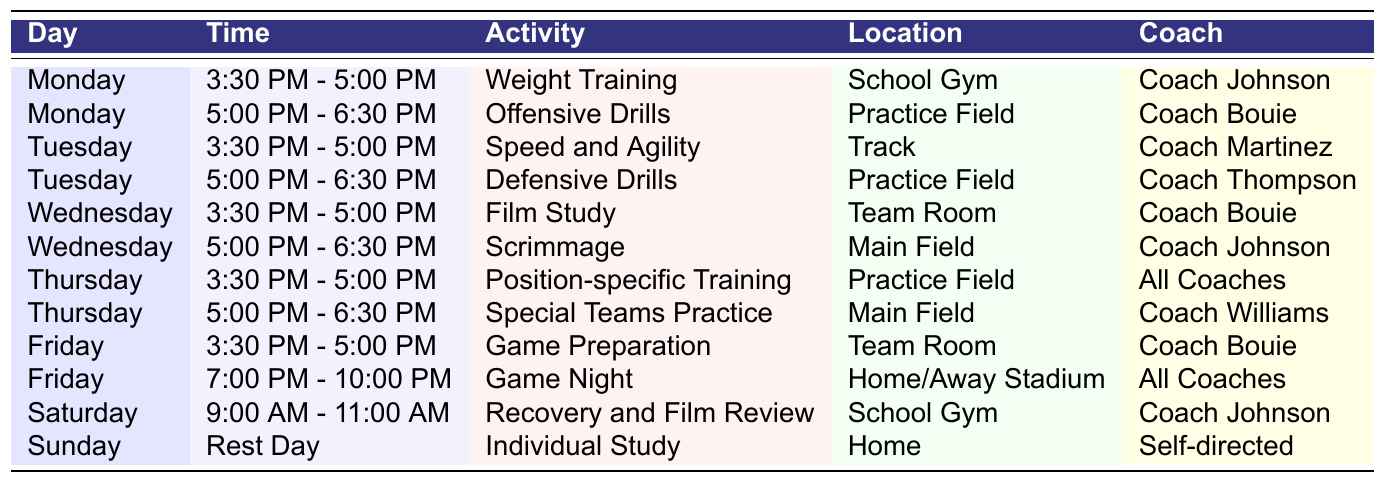What activities take place on Wednesday? The table lists the activities scheduled for Wednesday, which are Film Study from 3:30 PM - 5:00 PM in the Team Room with Coach Bouie, and Scrimmage from 5:00 PM - 6:30 PM on the Main Field with Coach Johnson.
Answer: Film Study and Scrimmage Which coach is responsible for the Defensive Drills? According to the table, the activity for Defensive Drills is scheduled on Tuesday from 5:00 PM - 6:30 PM in the Practice Field, and it is led by Coach Thompson.
Answer: Coach Thompson How many different activities occur on Thursday? The table specifies that two activities are scheduled on Thursday: Position-specific Training from 3:30 PM - 5:00 PM, and Special Teams Practice from 5:00 PM - 6:30 PM. Therefore, there are 2 activities on that day.
Answer: 2 What is the time slot for Game Night? The entry for Game Night indicates that it occurs on Friday from 7:00 PM - 10:00 PM at Home/Away Stadium, as reflected in the table.
Answer: 7:00 PM - 10:00 PM Is there any activity on Sunday? The table shows that Sunday is a Rest Day, but there is an activity labeled "Individual Study" mentioned for Home, which is self-directed. Therefore, there is an activity on Sunday.
Answer: Yes How many sessions involve Coach Bouie? Reviewing the table for Coach Bouie's activities: Offensive Drills on Monday, Film Study on Wednesday, and Game Preparation on Friday. These count up to 3 sessions involving Coach Bouie.
Answer: 3 What is the total duration for the Weight Training session? The Weight Training session is scheduled from 3:30 PM - 5:00 PM, which is a 1.5-hour session.
Answer: 1.5 hours Which day has the least number of planned activities? Sunday only lists the Rest Day along with the Individual Study activity, making it the day with the least planned activities at just 1.
Answer: Sunday What are the main locations used for training throughout the week? The table lists various locations, including School Gym, Practice Field, Track, Team Room, Main Field, and Home/Away Stadium as the main training locations through the week.
Answer: School Gym, Practice Field, Track, Team Room, Main Field, Home/Away Stadium What activities take place after Wednesday? After Wednesday, the scheduled activities are: Position-specific Training on Thursday, Special Teams Practice on Thursday, Game Preparation on Friday, Game Night on Friday, Recovery and Film Review on Saturday, and Individual Study on Sunday.
Answer: 6 activities 